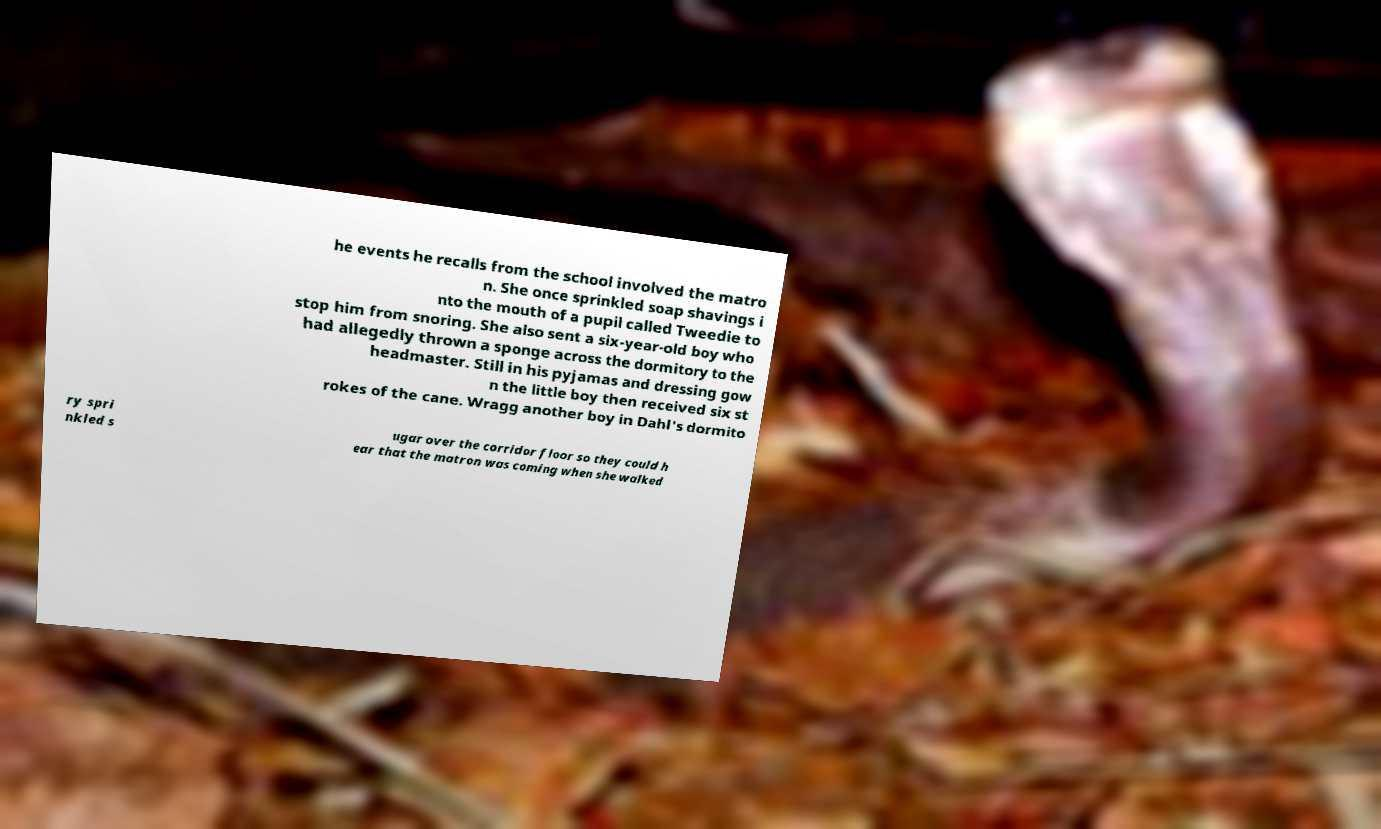What messages or text are displayed in this image? I need them in a readable, typed format. he events he recalls from the school involved the matro n. She once sprinkled soap shavings i nto the mouth of a pupil called Tweedie to stop him from snoring. She also sent a six-year-old boy who had allegedly thrown a sponge across the dormitory to the headmaster. Still in his pyjamas and dressing gow n the little boy then received six st rokes of the cane. Wragg another boy in Dahl's dormito ry spri nkled s ugar over the corridor floor so they could h ear that the matron was coming when she walked 